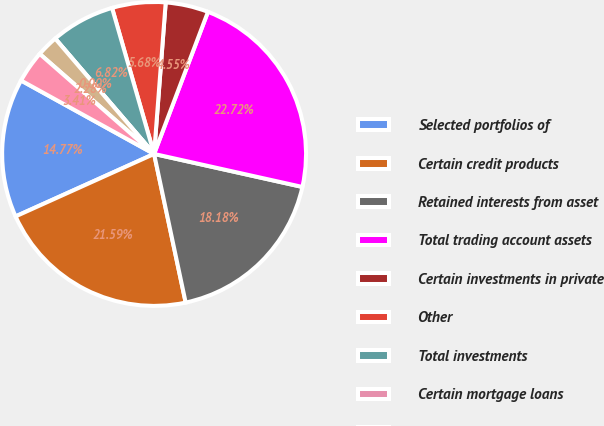Convert chart to OTSL. <chart><loc_0><loc_0><loc_500><loc_500><pie_chart><fcel>Selected portfolios of<fcel>Certain credit products<fcel>Retained interests from asset<fcel>Total trading account assets<fcel>Certain investments in private<fcel>Other<fcel>Total investments<fcel>Certain mortgage loans<fcel>Certain hybrid financial<fcel>Total loans<nl><fcel>14.77%<fcel>21.59%<fcel>18.18%<fcel>22.72%<fcel>4.55%<fcel>5.68%<fcel>6.82%<fcel>0.0%<fcel>2.28%<fcel>3.41%<nl></chart> 